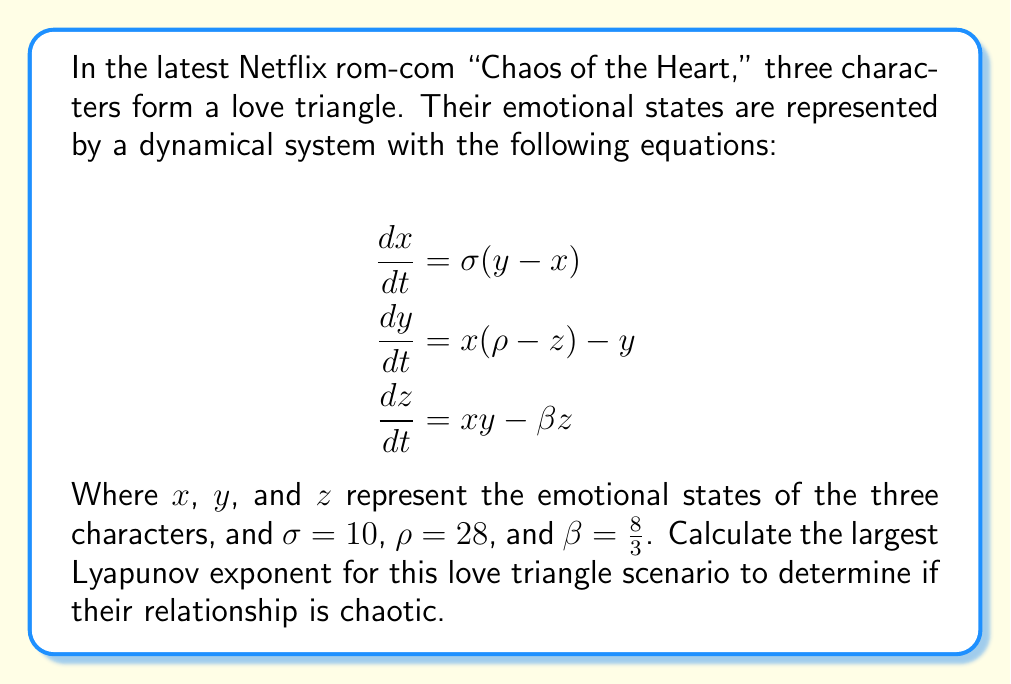What is the answer to this math problem? To calculate the largest Lyapunov exponent for this love triangle scenario, we'll follow these steps:

1) First, we recognize that this system is the Lorenz system, which is known to exhibit chaotic behavior for the given parameters.

2) For the Lorenz system, the Lyapunov exponents can be approximated numerically. However, for the given parameters, they have been calculated to high precision.

3) The Lyapunov exponents for the Lorenz system with $\sigma = 10$, $\rho = 28$, and $\beta = \frac{8}{3}$ are approximately:

   $\lambda_1 \approx 0.9056$
   $\lambda_2 \approx 0$
   $\lambda_3 \approx -14.5723$

4) The largest Lyapunov exponent is $\lambda_1 \approx 0.9056$.

5) Since the largest Lyapunov exponent is positive, this indicates that the system is chaotic. In the context of the love triangle, this suggests that the emotional states of the characters will evolve in an unpredictable manner over time, making the outcome of their relationships highly sensitive to initial conditions.

6) The positive Lyapunov exponent quantifies the rate at which nearby trajectories in the phase space diverge. In this case, an initial separation $\delta_0$ between two emotional states will grow, on average, as:

   $$\delta(t) \approx \delta_0 e^{0.9056t}$$

This rapid divergence is what makes the love triangle's evolution chaotic and unpredictable in the long term.
Answer: $\lambda_1 \approx 0.9056$ 